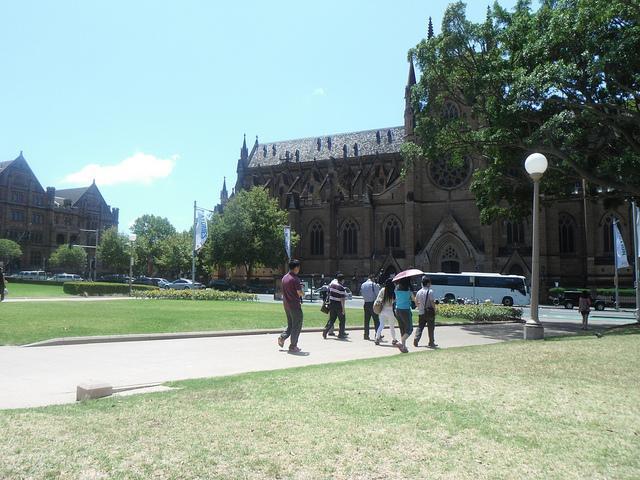How many cake clouds are there?
Give a very brief answer. 0. 